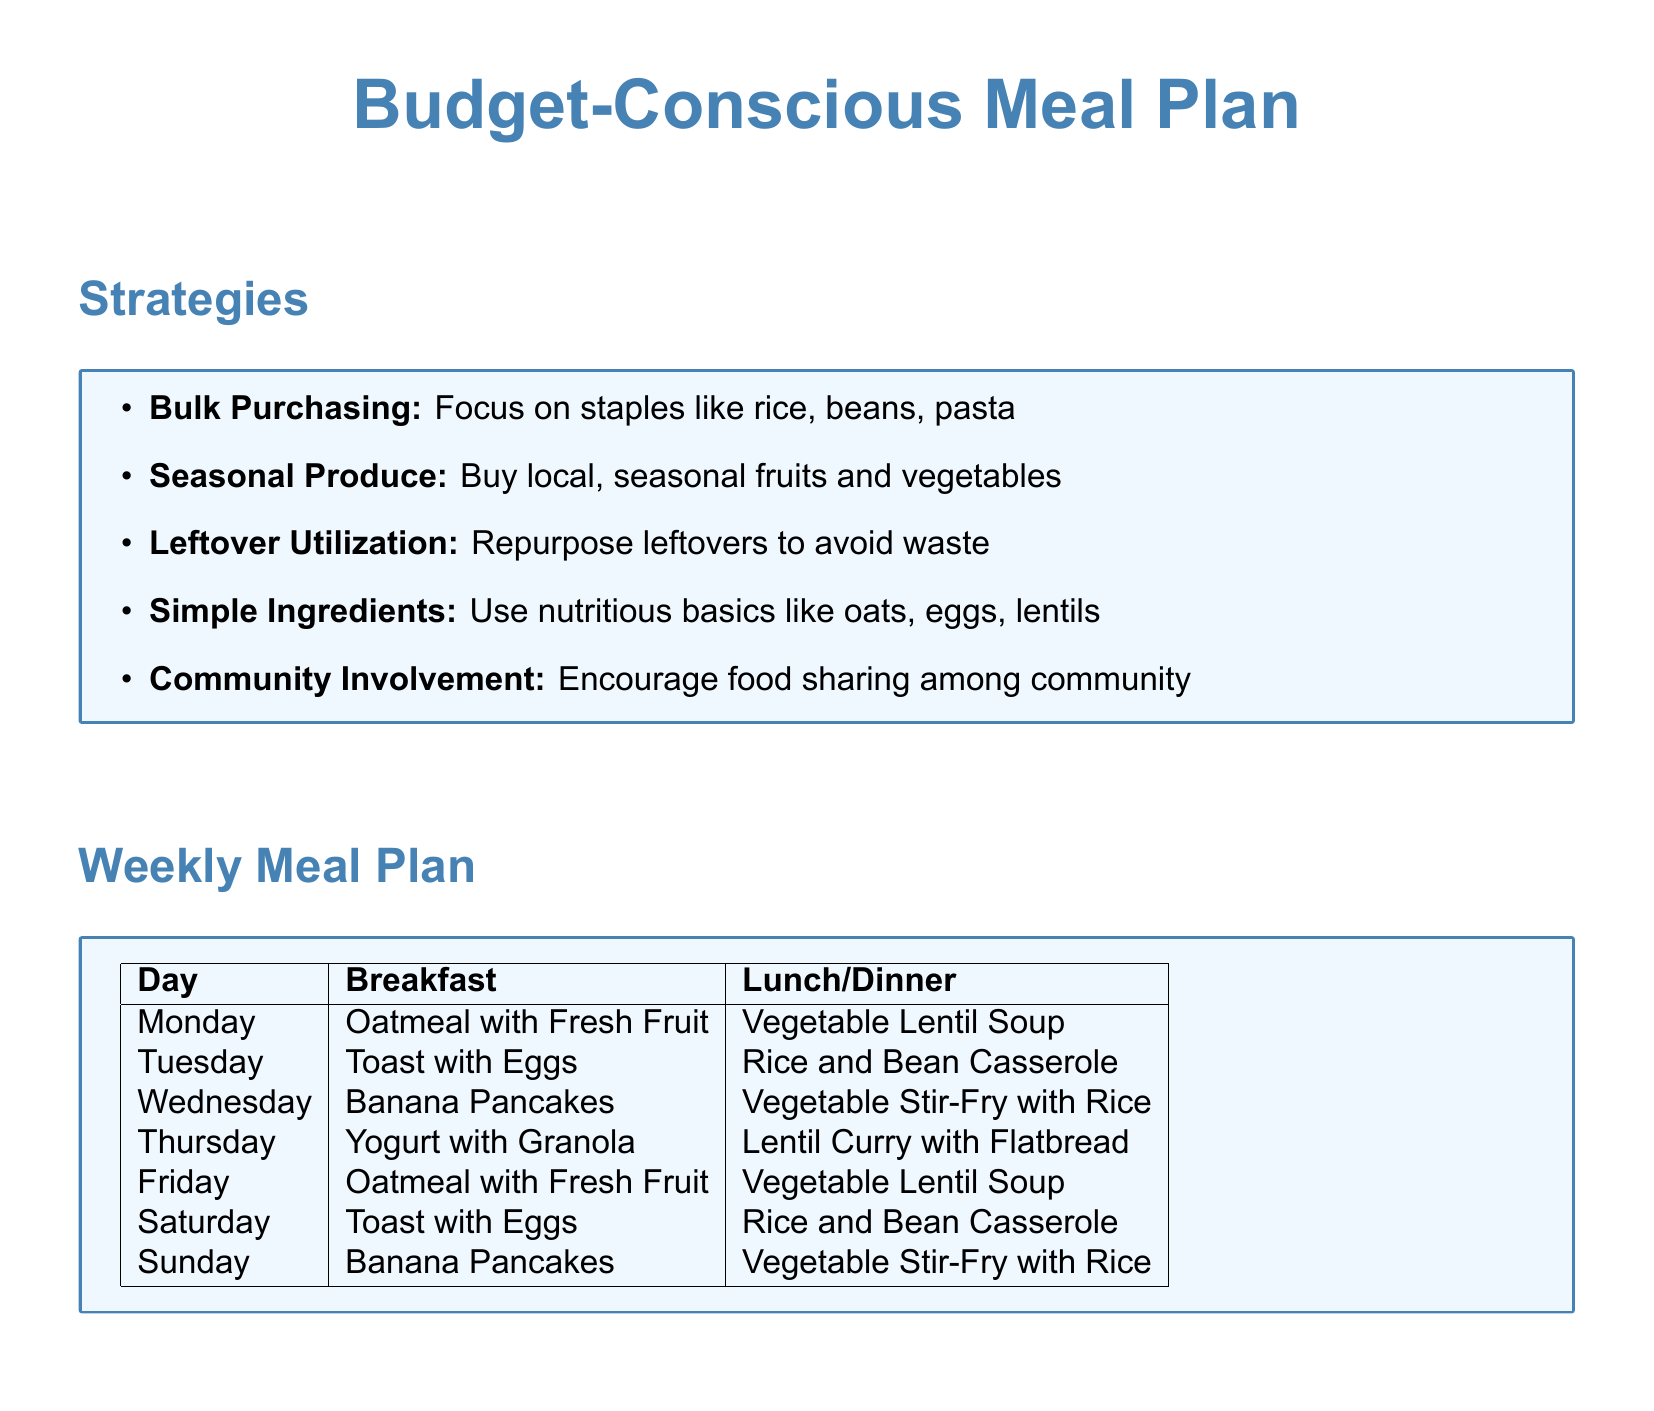What is the title of the document? The title is stated at the beginning of the document, reflecting the focus on meal planning for budget-conscious contexts.
Answer: Budget-Conscious Meal Plan What is one strategy for budget-conscious meal planning? The strategies section lists various methods, such as bulk purchasing, to maximize resources for meal planning.
Answer: Bulk Purchasing How many cups of water or vegetable broth are required for the Vegetable Lentil Soup? The recipe details the amount of liquid required for preparation, indicating essential ingredients.
Answer: 4 cups What day features Banana Pancakes for breakfast? The weekly meal plan outlines specific meals for each day, showing the schedule of breakfasts.
Answer: Wednesday What ingredient is NOT listed in the Vegetable Lentil Soup recipe? The ingredients section enumerates items needed, and assessing it helps identify what is omitted in the recipe.
Answer: Potatoes How many servings of Oatmeal with Fresh Fruit are listed in the meal plan? The breakfast section reveals the repeated meals throughout the week, indicating frequency and serving size.
Answer: 3 servings What type of soup is featured in the meal plan? The document specifies a particular recipe type as part of its structured meal offerings, central to the plan.
Answer: Vegetable Lentil Soup On which day are Rice and Bean Casseroles served? The meal plan conveys specific combinations of meals assigned to named days, assisting in meal preparation.
Answer: Tuesday Which two main ingredients are common in the lunch/dinner options? Analyzing the lunch/dinner section helps identify recurring staple foods utilized in the programs.
Answer: Rice and Beans 